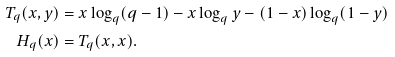Convert formula to latex. <formula><loc_0><loc_0><loc_500><loc_500>T _ { q } ( x , y ) & = x \log _ { q } ( q - 1 ) - x \log _ { q } y - ( 1 - x ) \log _ { q } ( 1 - y ) \\ H _ { q } ( x ) & = T _ { q } ( x , x ) .</formula> 